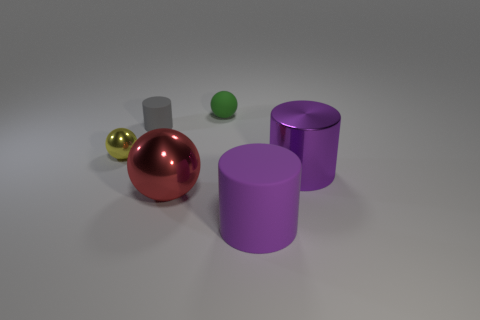What number of tiny metallic spheres are right of the small green matte thing?
Keep it short and to the point. 0. How many gray things are shiny spheres or matte balls?
Provide a succinct answer. 0. There is a cylinder that is the same size as the yellow sphere; what material is it?
Provide a succinct answer. Rubber. There is a rubber object that is on the right side of the gray object and behind the yellow metallic object; what is its shape?
Your answer should be very brief. Sphere. The metallic ball that is the same size as the gray thing is what color?
Provide a succinct answer. Yellow. Does the shiny ball that is left of the tiny gray rubber object have the same size as the metallic sphere in front of the yellow object?
Offer a very short reply. No. What is the size of the matte cylinder in front of the metallic object that is on the right side of the small sphere that is on the right side of the gray matte cylinder?
Offer a terse response. Large. There is a small matte thing that is on the left side of the small rubber thing that is right of the small gray rubber cylinder; what shape is it?
Offer a terse response. Cylinder. There is a metal thing to the left of the gray matte cylinder; is it the same color as the rubber ball?
Make the answer very short. No. What color is the small thing that is to the right of the yellow thing and in front of the matte sphere?
Your response must be concise. Gray. 